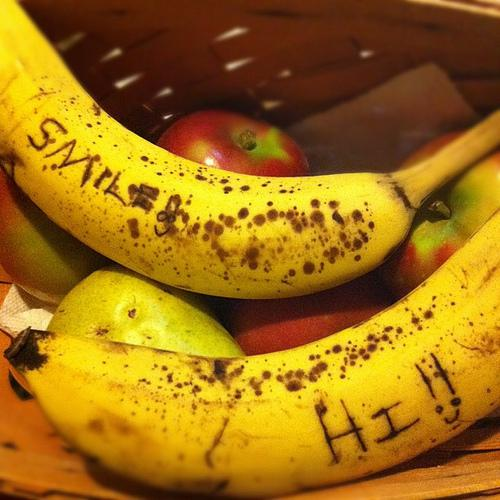Question: what fruit is in the forefront of this picture?
Choices:
A. Orange.
B. Apple.
C. Peach.
D. Banana.
Answer with the letter. Answer: D Question: what is carved into the banana on the bottom?
Choices:
A. Hello!.
B. Bye!.
C. Yes!.
D. Hi.
Answer with the letter. Answer: D Question: how are the fruit stored?
Choices:
A. In a plastic bag.
B. In a basket.
C. In a wooden crate.
D. In a bowl.
Answer with the letter. Answer: B Question: what fruit is there the most (number) of?
Choices:
A. Bananas.
B. Oranges.
C. Apples.
D. Pineapples.
Answer with the letter. Answer: C Question: what is in this basket?
Choices:
A. Vegetables.
B. Bread.
C. Meat.
D. Fruit.
Answer with the letter. Answer: D Question: why are the exclamation points different from normal?
Choices:
A. They're upside down.
B. The dots are hearts.
C. They've been made into smiley faces.
D. The dots are stars.
Answer with the letter. Answer: C 